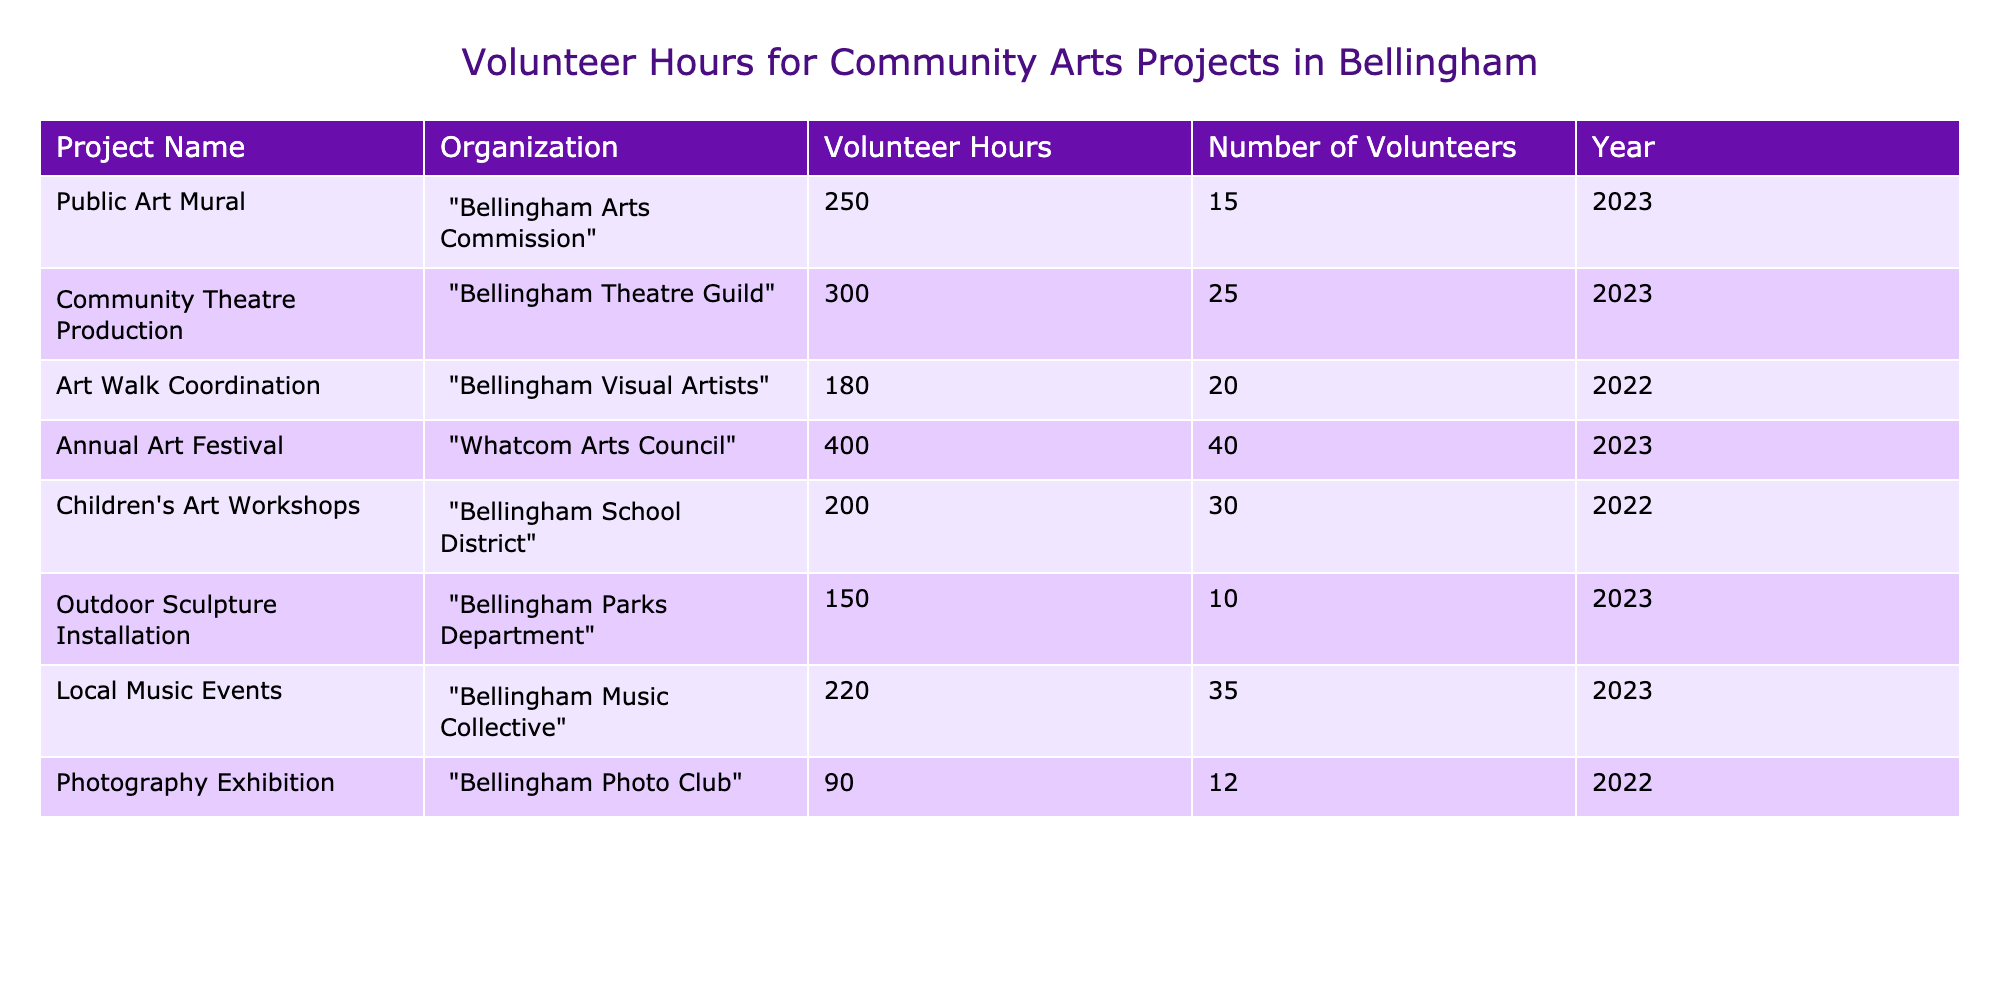What is the total number of volunteer hours contributed to the "Annual Art Festival"? The "Annual Art Festival" is listed in the table with 400 volunteer hours.
Answer: 400 Which project had the most volunteers in 2023? The "Community Theatre Production" had 25 volunteers, while the "Annual Art Festival" had 40 volunteers. Therefore, the "Annual Art Festival" had the most volunteers in 2023.
Answer: Annual Art Festival What is the average number of volunteer hours contributed by the projects in 2023? The projects in 2023 are "Public Art Mural" (250), "Community Theatre Production" (300), "Annual Art Festival" (400), "Outdoor Sculpture Installation" (150), and "Local Music Events" (220). The total is 1320 hours, and there are 5 projects, so the average is 1320/5 = 264 hours.
Answer: 264 Are there any projects from the Bellingham School District in the data? The "Children's Art Workshops" project is listed under the Bellingham School District, confirming there is a project from this organization in the data.
Answer: Yes Which project had the least volunteer hours, and what is their value? The project with the least volunteer hours is the "Photography Exhibition," with 90 hours contributed.
Answer: Photography Exhibition, 90 What is the difference in volunteer hours between the "Community Theatre Production" and the "Local Music Events"? The "Community Theatre Production" had 300 hours, while the "Local Music Events" had 220 hours. The difference is 300 - 220 = 80 hours.
Answer: 80 What percentage of the total volunteer hours came from the "Children's Art Workshops" in 2022? The "Children's Art Workshops" had 200 hours, and the total volunteer hours from all projects are 250 + 300 + 180 + 400 + 200 + 150 + 220 + 90 = 1890. So, the percentage is (200/1890) * 100 ≈ 10.58%.
Answer: 10.58% Which organization contributed to the least amount of volunteer hours in 2022? The 2022 projects in the table are "Art Walk Coordination" (180), "Children's Art Workshops" (200), and "Photography Exhibition" (90). The "Photography Exhibition" had the least amount of volunteer hours.
Answer: Bellingham Photo Club What is the total number of volunteers across all projects in 2023? The total number of volunteers in 2023 is calculated by adding the volunteers from each project: "Public Art Mural" (15) + "Community Theatre Production" (25) + "Annual Art Festival" (40) + "Outdoor Sculpture Installation" (10) + "Local Music Events" (35) = 125.
Answer: 125 